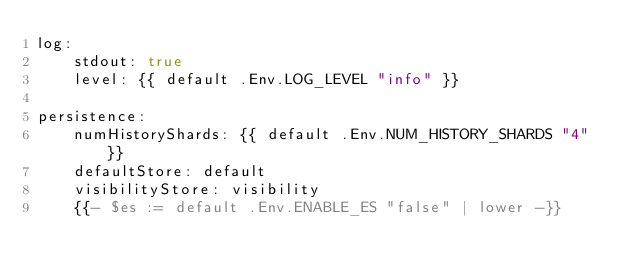Convert code to text. <code><loc_0><loc_0><loc_500><loc_500><_YAML_>log:
    stdout: true
    level: {{ default .Env.LOG_LEVEL "info" }}

persistence:
    numHistoryShards: {{ default .Env.NUM_HISTORY_SHARDS "4" }}
    defaultStore: default
    visibilityStore: visibility
    {{- $es := default .Env.ENABLE_ES "false" | lower -}}</code> 